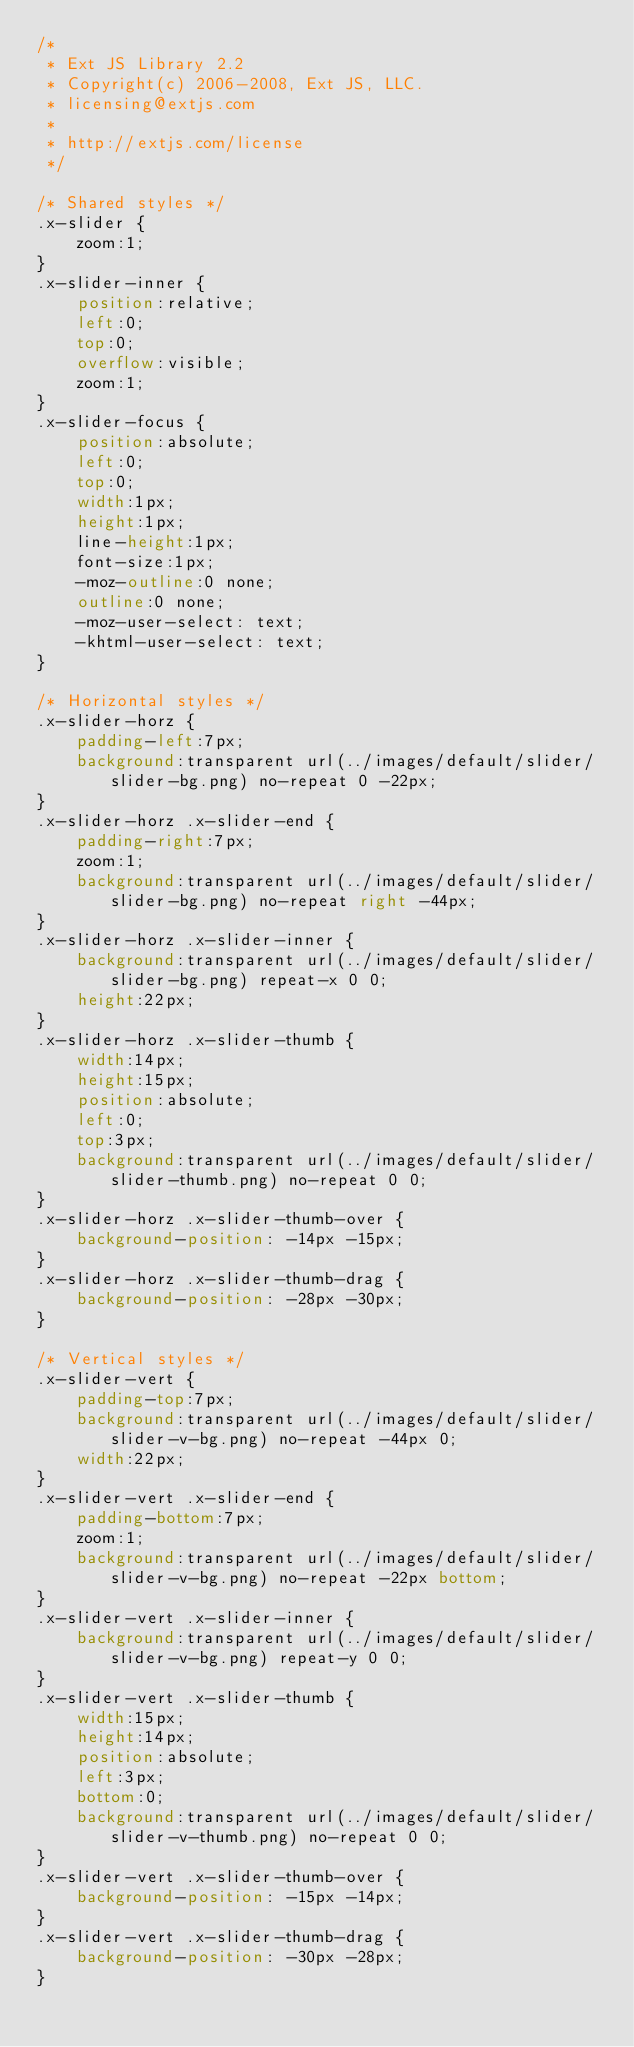<code> <loc_0><loc_0><loc_500><loc_500><_CSS_>/*
 * Ext JS Library 2.2
 * Copyright(c) 2006-2008, Ext JS, LLC.
 * licensing@extjs.com
 * 
 * http://extjs.com/license
 */

/* Shared styles */
.x-slider {
    zoom:1;
}
.x-slider-inner {
    position:relative;
    left:0;
    top:0;
    overflow:visible;
    zoom:1;
}
.x-slider-focus {
	position:absolute;
	left:0;
	top:0;
	width:1px;
	height:1px;
    line-height:1px;
    font-size:1px;
    -moz-outline:0 none;
    outline:0 none;
    -moz-user-select: text;
    -khtml-user-select: text;
}

/* Horizontal styles */
.x-slider-horz {
    padding-left:7px;
    background:transparent url(../images/default/slider/slider-bg.png) no-repeat 0 -22px;
}
.x-slider-horz .x-slider-end {
    padding-right:7px;
    zoom:1;
    background:transparent url(../images/default/slider/slider-bg.png) no-repeat right -44px;
}
.x-slider-horz .x-slider-inner {
    background:transparent url(../images/default/slider/slider-bg.png) repeat-x 0 0;
    height:22px;
}
.x-slider-horz .x-slider-thumb {
    width:14px;
    height:15px;
    position:absolute;
    left:0;
    top:3px;
    background:transparent url(../images/default/slider/slider-thumb.png) no-repeat 0 0;
}
.x-slider-horz .x-slider-thumb-over {
    background-position: -14px -15px;
}
.x-slider-horz .x-slider-thumb-drag {
    background-position: -28px -30px;
}

/* Vertical styles */
.x-slider-vert {
    padding-top:7px;
    background:transparent url(../images/default/slider/slider-v-bg.png) no-repeat -44px 0;
    width:22px;
}
.x-slider-vert .x-slider-end {
    padding-bottom:7px;
    zoom:1;
    background:transparent url(../images/default/slider/slider-v-bg.png) no-repeat -22px bottom;
}
.x-slider-vert .x-slider-inner {
    background:transparent url(../images/default/slider/slider-v-bg.png) repeat-y 0 0;
}
.x-slider-vert .x-slider-thumb {
    width:15px;
    height:14px;
    position:absolute;
    left:3px;
    bottom:0;
    background:transparent url(../images/default/slider/slider-v-thumb.png) no-repeat 0 0;
}
.x-slider-vert .x-slider-thumb-over {
    background-position: -15px -14px;
}
.x-slider-vert .x-slider-thumb-drag {
    background-position: -30px -28px;
}
</code> 